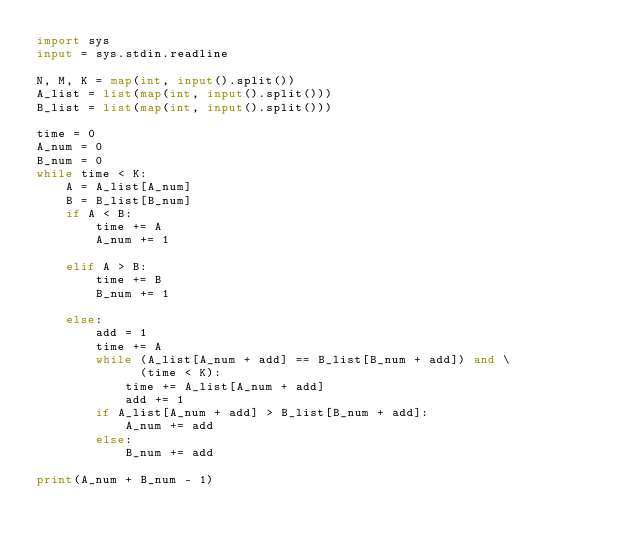<code> <loc_0><loc_0><loc_500><loc_500><_Python_>import sys
input = sys.stdin.readline

N, M, K = map(int, input().split())
A_list = list(map(int, input().split()))
B_list = list(map(int, input().split()))

time = 0
A_num = 0
B_num = 0
while time < K:
    A = A_list[A_num]
    B = B_list[B_num]
    if A < B:
        time += A
        A_num += 1

    elif A > B:
        time += B
        B_num += 1

    else:
        add = 1
        time += A
        while (A_list[A_num + add] == B_list[B_num + add]) and \
              (time < K):
            time += A_list[A_num + add]
            add += 1
        if A_list[A_num + add] > B_list[B_num + add]:
            A_num += add
        else:
            B_num += add

print(A_num + B_num - 1)</code> 